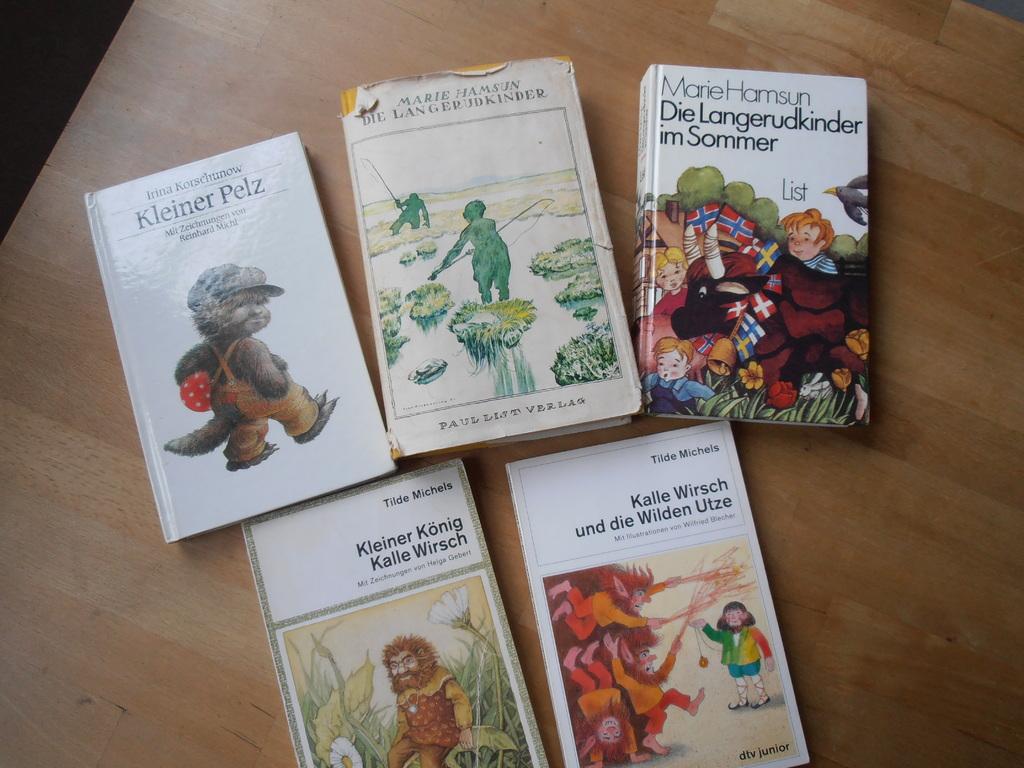What is the title of the top left book?
Keep it short and to the point. Kleiner pelz. 